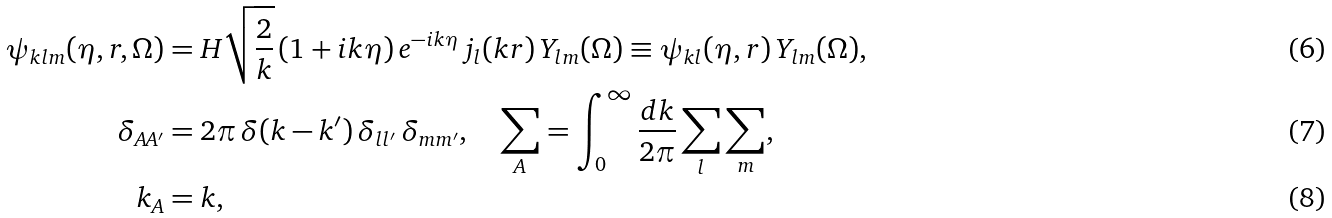Convert formula to latex. <formula><loc_0><loc_0><loc_500><loc_500>\psi _ { k l m } ( \eta , r , \Omega ) & = H \sqrt { \frac { 2 } { k } } \, ( 1 + i k \eta ) \, e ^ { - i k \eta } \, j _ { l } ( k r ) \, Y _ { l m } ( \Omega ) \equiv \psi _ { k l } ( \eta , r ) \, Y _ { l m } ( \Omega ) , \\ \delta _ { A A ^ { \prime } } & = 2 \pi \, \delta ( k - k ^ { \prime } ) \, \delta _ { l l ^ { \prime } } \, \delta _ { m m ^ { \prime } } , \quad \sum _ { A } = \int _ { 0 } ^ { \infty } \frac { d k } { 2 \pi } \sum _ { l } \sum _ { m } , \\ k _ { A } & = k ,</formula> 